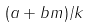Convert formula to latex. <formula><loc_0><loc_0><loc_500><loc_500>( a + b m ) / k</formula> 